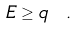Convert formula to latex. <formula><loc_0><loc_0><loc_500><loc_500>E \geq q \ .</formula> 